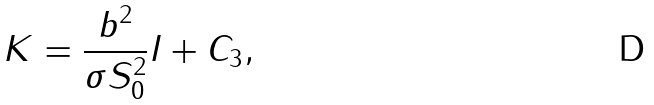Convert formula to latex. <formula><loc_0><loc_0><loc_500><loc_500>K = \frac { b ^ { 2 } } { \sigma S _ { 0 } ^ { 2 } } I + C _ { 3 } ,</formula> 